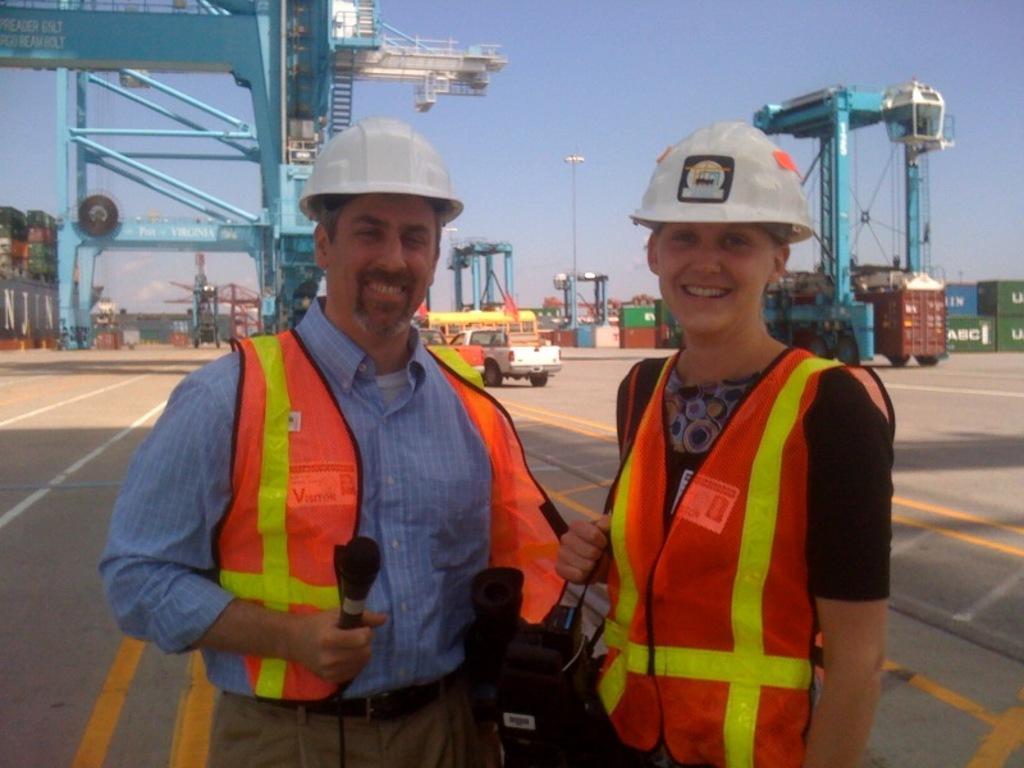Please provide a concise description of this image. In this image, we can see two persons standing and they are wearing white color helmets, in the background there is a car and at the top there is a sky. 